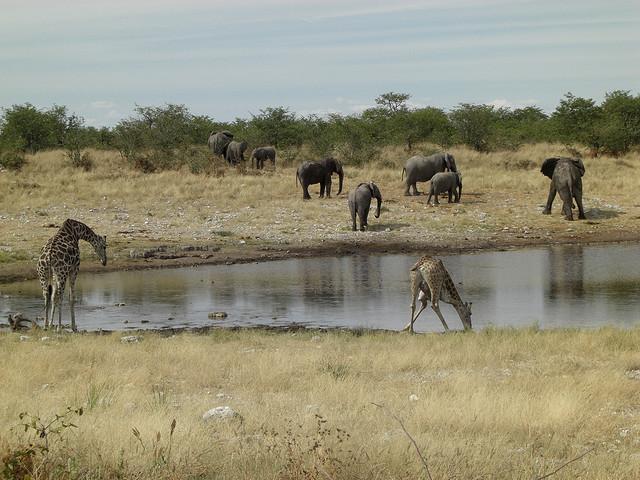How many animals are present?
Give a very brief answer. 10. How many giraffes can you see?
Give a very brief answer. 2. 